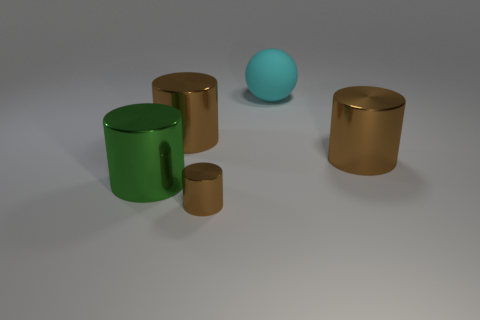Add 3 big blue objects. How many objects exist? 8 Subtract all gray blocks. How many brown cylinders are left? 3 Subtract all large metal cylinders. How many cylinders are left? 1 Subtract all green cylinders. How many cylinders are left? 3 Subtract all cylinders. How many objects are left? 1 Subtract 0 red balls. How many objects are left? 5 Subtract all yellow cylinders. Subtract all yellow spheres. How many cylinders are left? 4 Subtract all small yellow metal cubes. Subtract all matte things. How many objects are left? 4 Add 1 green metal things. How many green metal things are left? 2 Add 3 tiny brown cylinders. How many tiny brown cylinders exist? 4 